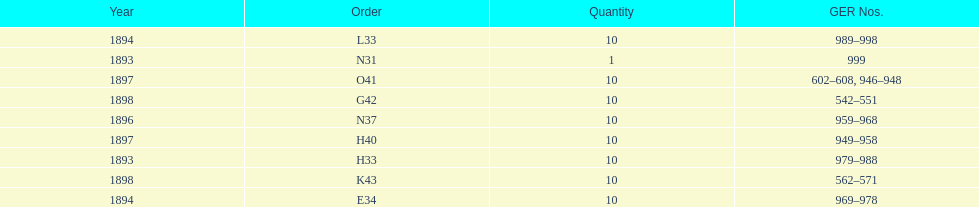Which had more ger numbers, 1898 or 1893? 1898. 